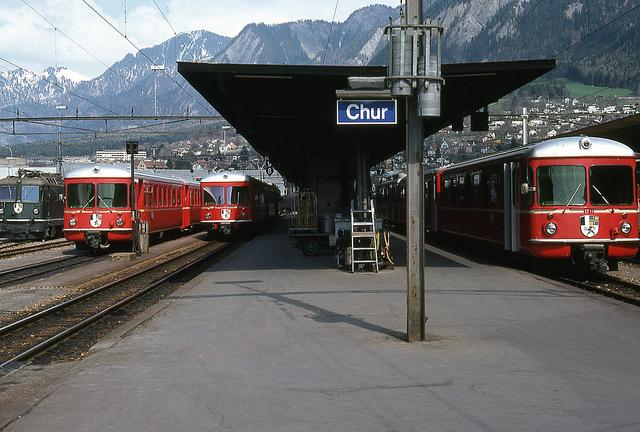What mountains are these? alps 